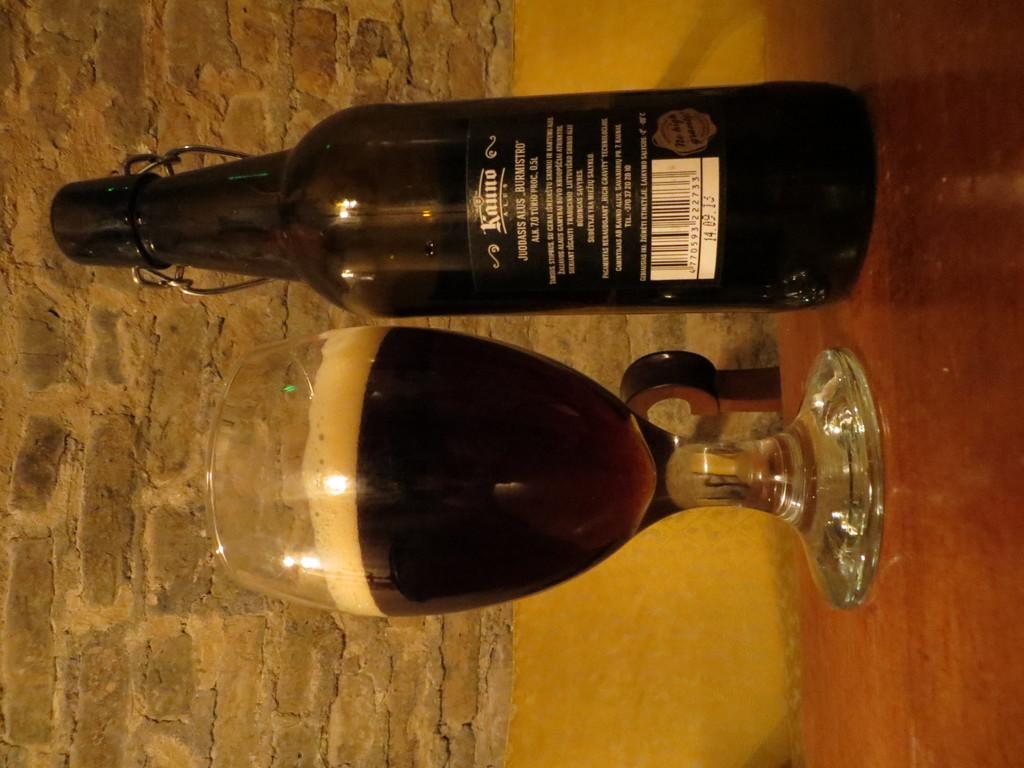<image>
Provide a brief description of the given image. A bottle of Kanno is in front of a brick wall and it is next to a glass. 